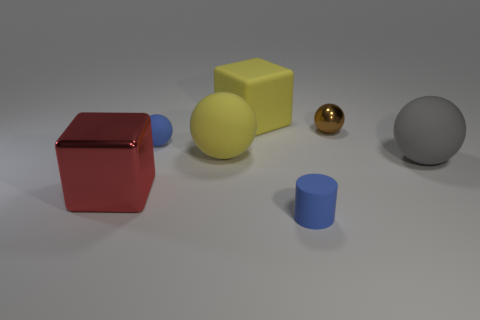Subtract 1 spheres. How many spheres are left? 3 Add 2 small gray matte cylinders. How many objects exist? 9 Subtract all balls. How many objects are left? 3 Add 6 small metal things. How many small metal things exist? 7 Subtract 0 green cylinders. How many objects are left? 7 Subtract all large yellow cubes. Subtract all big red metallic cubes. How many objects are left? 5 Add 5 small blue cylinders. How many small blue cylinders are left? 6 